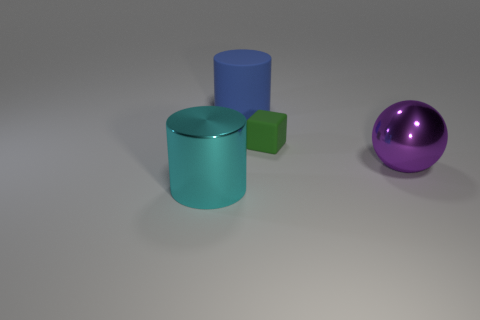Are there any blue rubber cylinders of the same size as the metallic sphere?
Give a very brief answer. Yes. How many green matte objects are behind the large metal object on the left side of the tiny green matte object?
Offer a very short reply. 1. What is the blue thing made of?
Ensure brevity in your answer.  Rubber. There is a small green object; how many large cylinders are behind it?
Make the answer very short. 1. Is the number of blue objects greater than the number of brown shiny objects?
Your answer should be compact. Yes. There is a thing that is to the left of the green cube and in front of the big rubber cylinder; how big is it?
Make the answer very short. Large. Does the big cylinder that is on the right side of the shiny cylinder have the same material as the tiny object behind the cyan thing?
Your answer should be compact. Yes. There is a cyan metal object that is the same size as the blue cylinder; what is its shape?
Offer a terse response. Cylinder. Is the number of cyan shiny objects less than the number of big metal objects?
Your answer should be very brief. Yes. There is a big cylinder that is behind the big purple thing; is there a rubber cylinder that is in front of it?
Provide a succinct answer. No. 